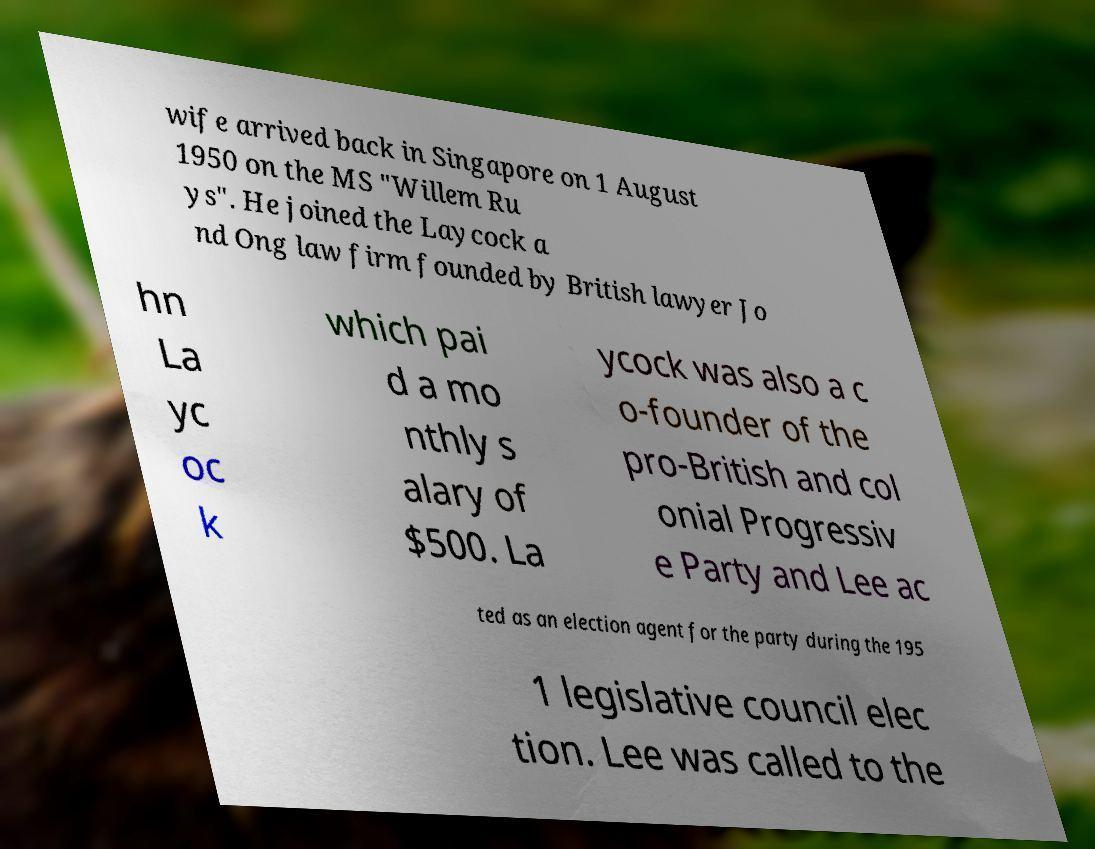Can you read and provide the text displayed in the image?This photo seems to have some interesting text. Can you extract and type it out for me? wife arrived back in Singapore on 1 August 1950 on the MS "Willem Ru ys". He joined the Laycock a nd Ong law firm founded by British lawyer Jo hn La yc oc k which pai d a mo nthly s alary of $500. La ycock was also a c o-founder of the pro-British and col onial Progressiv e Party and Lee ac ted as an election agent for the party during the 195 1 legislative council elec tion. Lee was called to the 